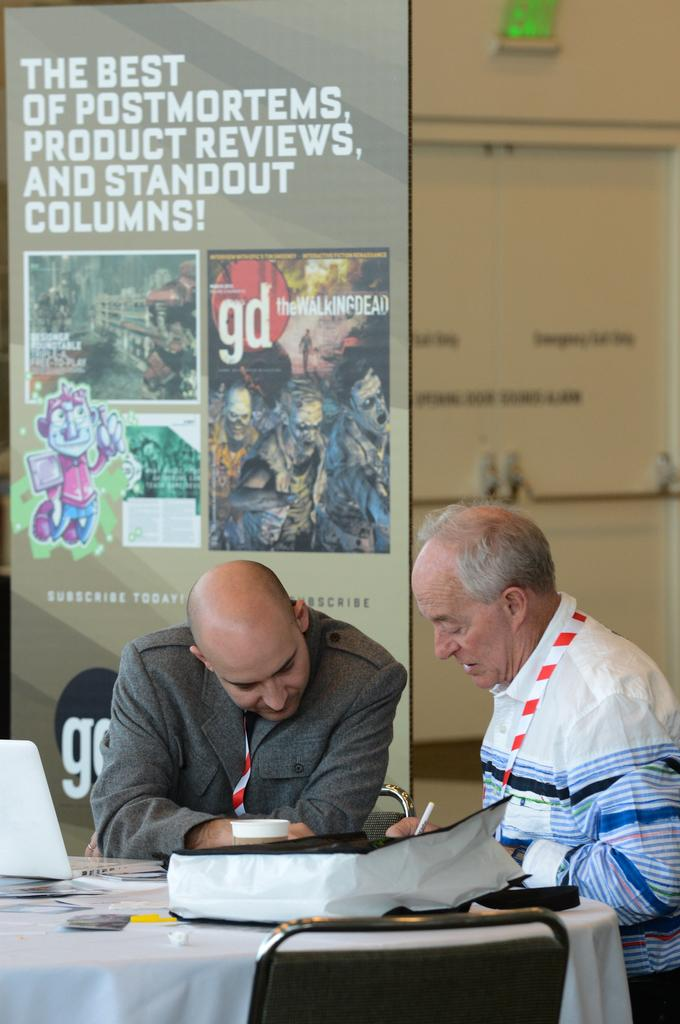<image>
Present a compact description of the photo's key features. Cover of the walking dead with a gd logo on a brochure. 